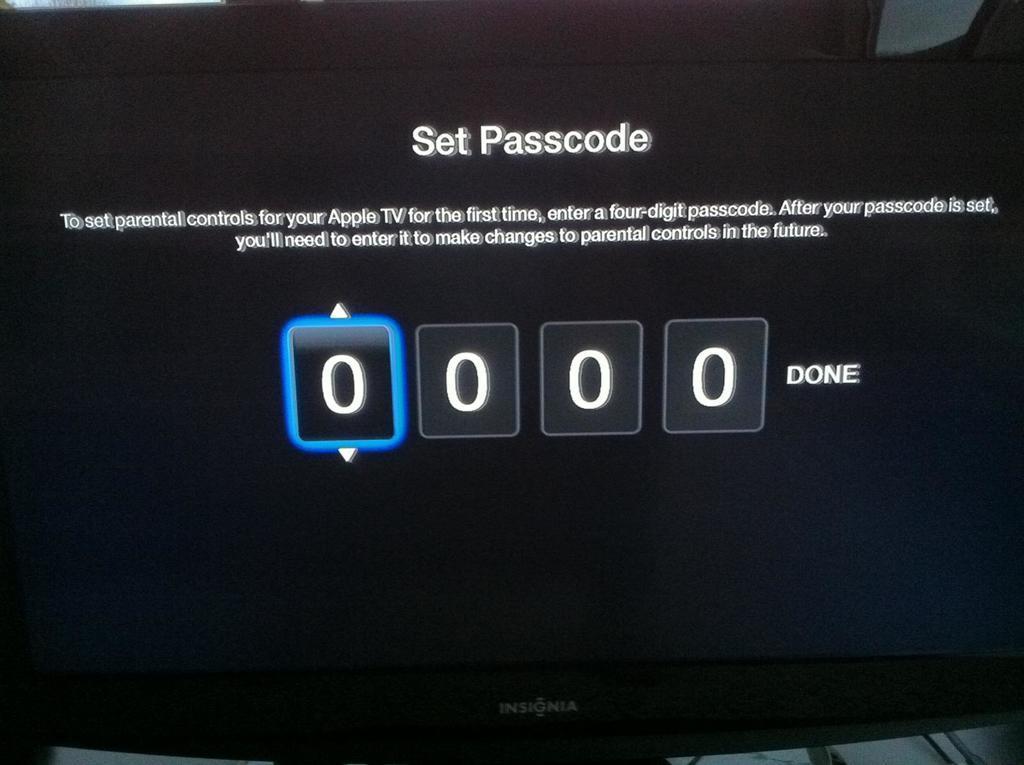Please provide a concise description of this image. In this image we can see a desktop with some text. 